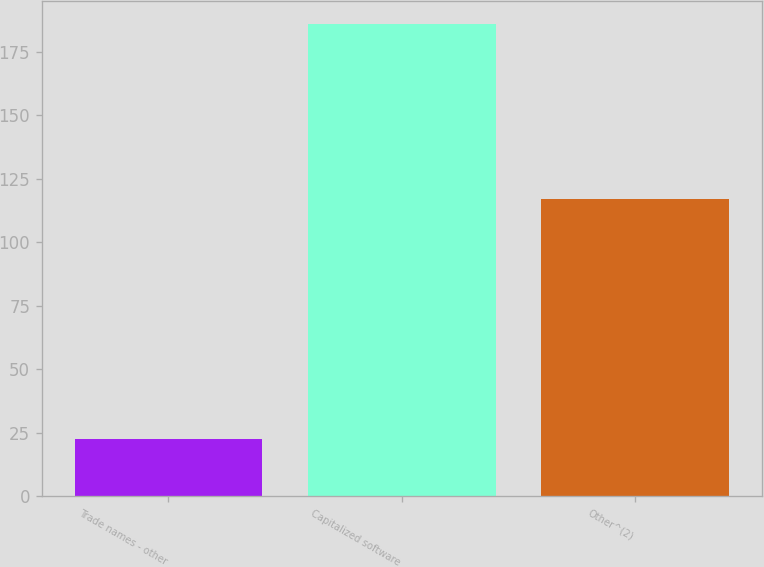Convert chart to OTSL. <chart><loc_0><loc_0><loc_500><loc_500><bar_chart><fcel>Trade names - other<fcel>Capitalized software<fcel>Other^(2)<nl><fcel>22.7<fcel>185.9<fcel>117.1<nl></chart> 